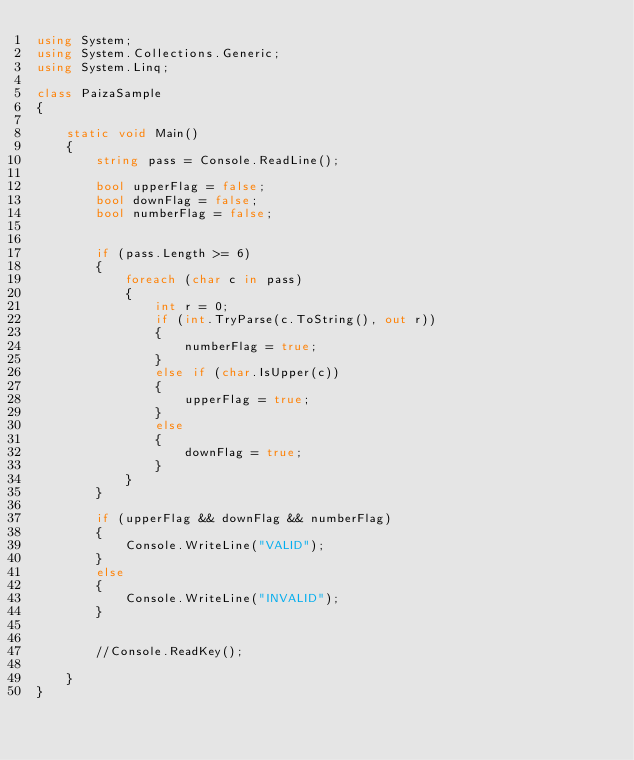Convert code to text. <code><loc_0><loc_0><loc_500><loc_500><_C#_>using System;
using System.Collections.Generic;
using System.Linq;

class PaizaSample
{

    static void Main()
    {
        string pass = Console.ReadLine();

        bool upperFlag = false;
        bool downFlag = false;
        bool numberFlag = false;


        if (pass.Length >= 6)
        {
            foreach (char c in pass)
            {
                int r = 0;
                if (int.TryParse(c.ToString(), out r))
                {
                    numberFlag = true;
                }
                else if (char.IsUpper(c))
                {
                    upperFlag = true;
                }
                else
                {
                    downFlag = true;
                }
            }
        }

        if (upperFlag && downFlag && numberFlag)
        {
            Console.WriteLine("VALID");
        }
        else
        {
            Console.WriteLine("INVALID");
        }


        //Console.ReadKey();

    }
}</code> 